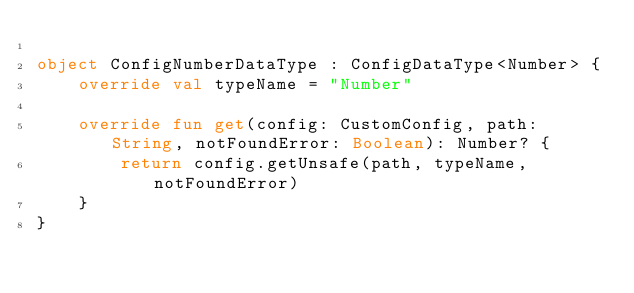Convert code to text. <code><loc_0><loc_0><loc_500><loc_500><_Kotlin_>
object ConfigNumberDataType : ConfigDataType<Number> {
    override val typeName = "Number"

    override fun get(config: CustomConfig, path: String, notFoundError: Boolean): Number? {
        return config.getUnsafe(path, typeName, notFoundError)
    }
}</code> 